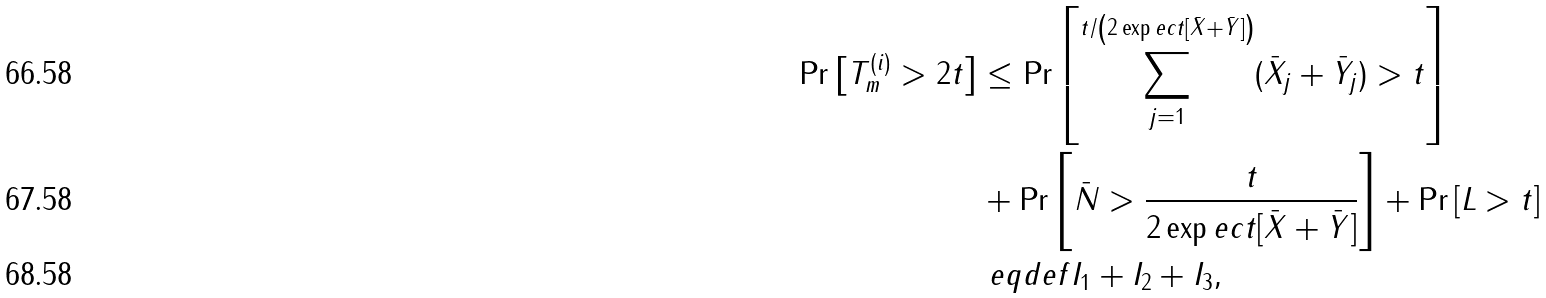<formula> <loc_0><loc_0><loc_500><loc_500>\Pr \left [ T _ { m } ^ { ( i ) } > 2 t \right ] & \leq \Pr \left [ \sum _ { j = 1 } ^ { t / \left ( 2 \exp e c t [ \bar { X } + \bar { Y } ] \right ) } ( \bar { X } _ { j } + \bar { Y } _ { j } ) > t \right ] \\ & + \Pr \left [ \bar { N } > \frac { t } { 2 \exp e c t [ \bar { X } + \bar { Y } ] } \right ] + \Pr \left [ L > t \right ] \\ & \ e q d e f I _ { 1 } + I _ { 2 } + I _ { 3 } ,</formula> 